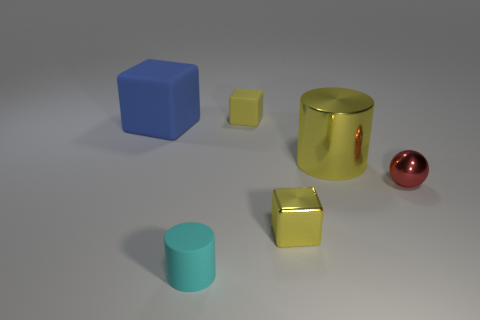Add 2 yellow cylinders. How many objects exist? 8 Subtract all tiny yellow cubes. How many cubes are left? 1 Subtract all yellow cubes. How many cubes are left? 1 Subtract all cylinders. How many objects are left? 4 Subtract all tiny shiny objects. Subtract all metallic cylinders. How many objects are left? 3 Add 4 metal things. How many metal things are left? 7 Add 6 large cylinders. How many large cylinders exist? 7 Subtract 0 gray spheres. How many objects are left? 6 Subtract 1 blocks. How many blocks are left? 2 Subtract all blue blocks. Subtract all green balls. How many blocks are left? 2 